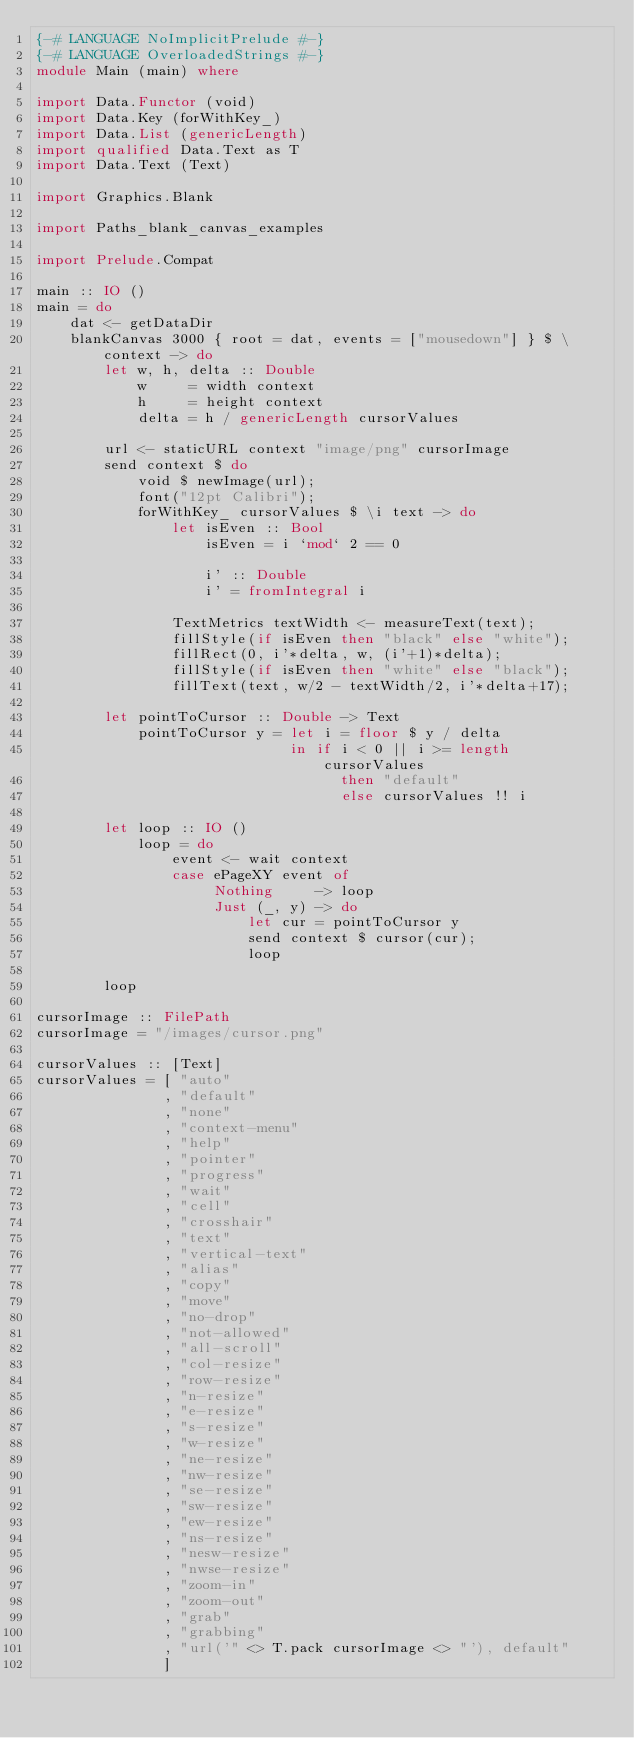<code> <loc_0><loc_0><loc_500><loc_500><_Haskell_>{-# LANGUAGE NoImplicitPrelude #-}
{-# LANGUAGE OverloadedStrings #-}
module Main (main) where

import Data.Functor (void)
import Data.Key (forWithKey_)
import Data.List (genericLength)
import qualified Data.Text as T
import Data.Text (Text)

import Graphics.Blank

import Paths_blank_canvas_examples

import Prelude.Compat

main :: IO ()
main = do
    dat <- getDataDir
    blankCanvas 3000 { root = dat, events = ["mousedown"] } $ \context -> do
        let w, h, delta :: Double
            w     = width context
            h     = height context
            delta = h / genericLength cursorValues

        url <- staticURL context "image/png" cursorImage
        send context $ do
            void $ newImage(url);
            font("12pt Calibri");
            forWithKey_ cursorValues $ \i text -> do
                let isEven :: Bool
                    isEven = i `mod` 2 == 0

                    i' :: Double
                    i' = fromIntegral i

                TextMetrics textWidth <- measureText(text);
                fillStyle(if isEven then "black" else "white");
                fillRect(0, i'*delta, w, (i'+1)*delta);
                fillStyle(if isEven then "white" else "black");
                fillText(text, w/2 - textWidth/2, i'*delta+17);

        let pointToCursor :: Double -> Text
            pointToCursor y = let i = floor $ y / delta
                              in if i < 0 || i >= length cursorValues
                                    then "default"
                                    else cursorValues !! i

        let loop :: IO ()
            loop = do
                event <- wait context
                case ePageXY event of
                     Nothing     -> loop
                     Just (_, y) -> do
                         let cur = pointToCursor y
                         send context $ cursor(cur);
                         loop

        loop

cursorImage :: FilePath
cursorImage = "/images/cursor.png"

cursorValues :: [Text]
cursorValues = [ "auto"
               , "default"
               , "none"
               , "context-menu"
               , "help"
               , "pointer"
               , "progress"
               , "wait"
               , "cell"
               , "crosshair"
               , "text"
               , "vertical-text"
               , "alias"
               , "copy"
               , "move"
               , "no-drop"
               , "not-allowed"
               , "all-scroll"
               , "col-resize"
               , "row-resize"
               , "n-resize"
               , "e-resize"
               , "s-resize"
               , "w-resize"
               , "ne-resize"
               , "nw-resize"
               , "se-resize"
               , "sw-resize"
               , "ew-resize"
               , "ns-resize"
               , "nesw-resize"
               , "nwse-resize"
               , "zoom-in"
               , "zoom-out"
               , "grab"
               , "grabbing"
               , "url('" <> T.pack cursorImage <> "'), default"
               ]
</code> 